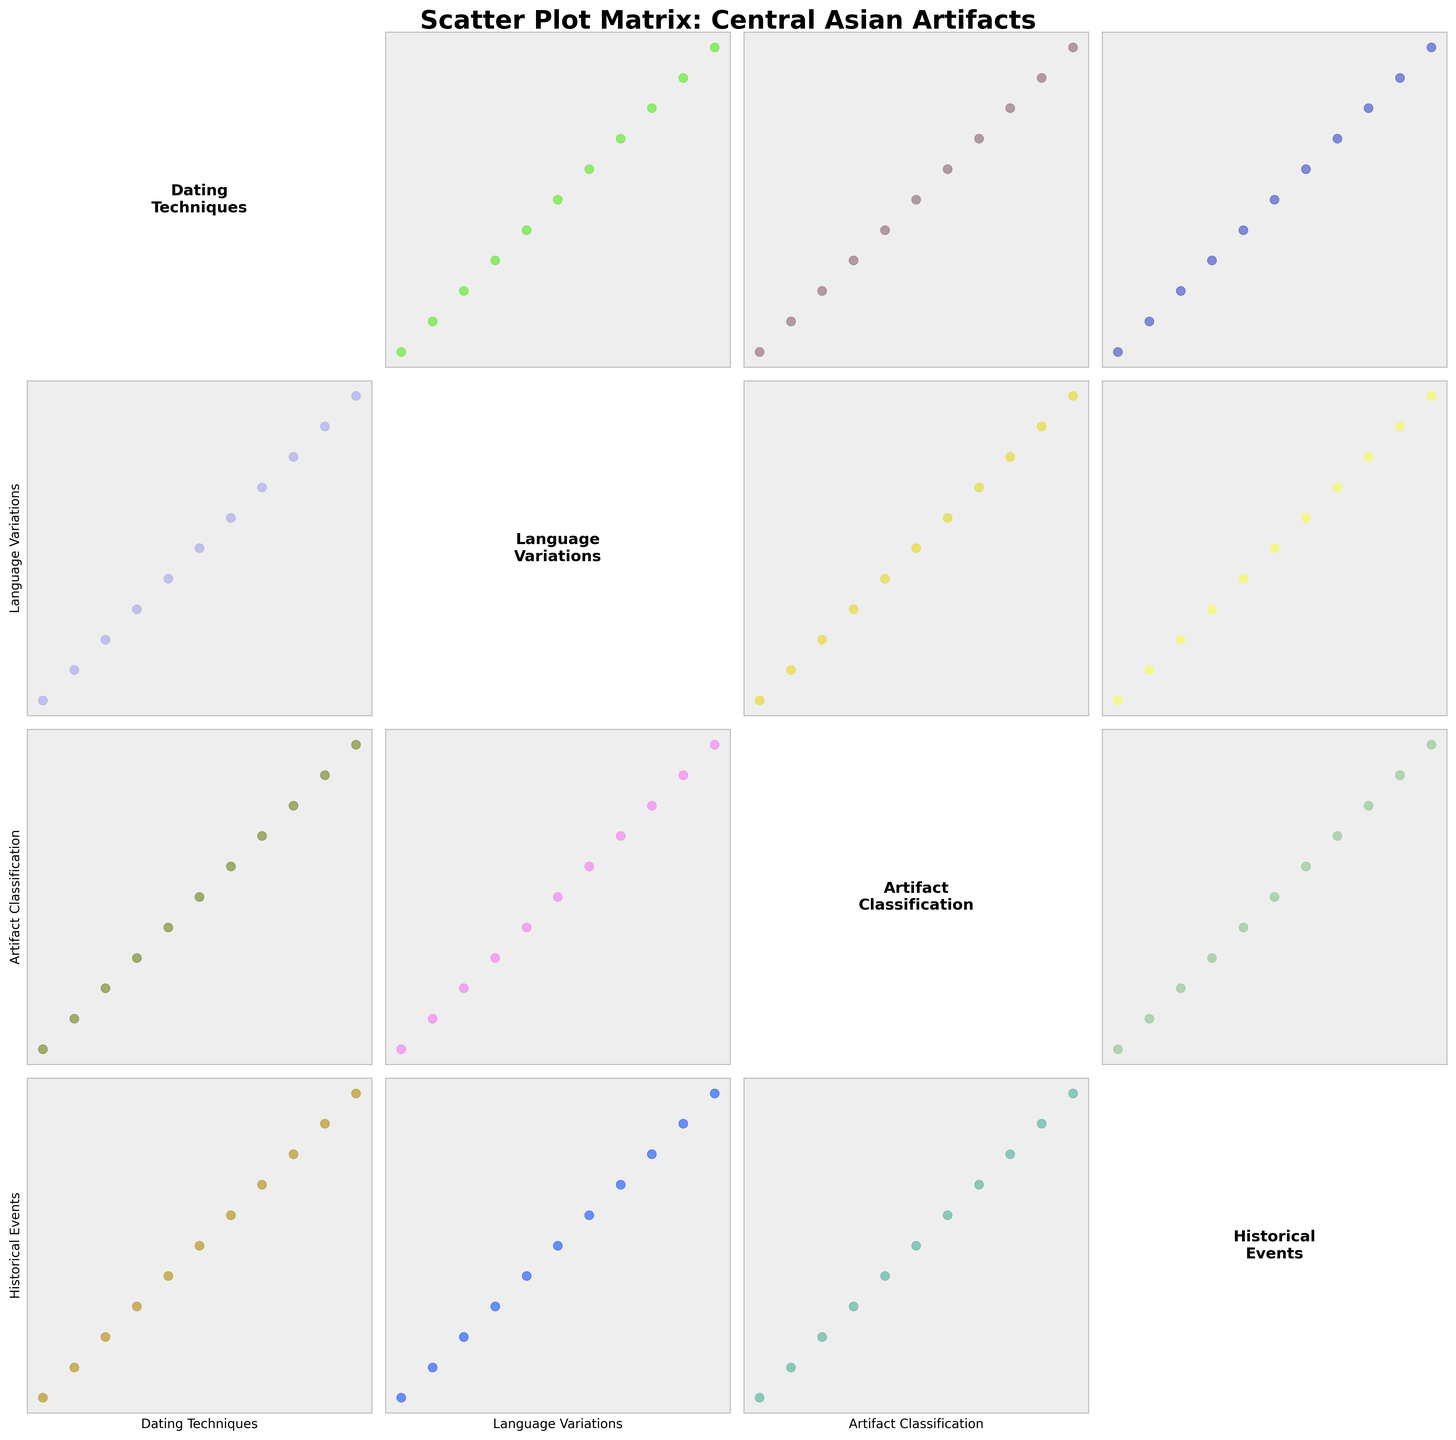what is the title of the figure? Look at the top of the figure where the title is placed. It's usually in large, bold fonts.
Answer: Scatter Plot Matrix: Central Asian Artifacts how many different categories are there in the plot? There are labels on both x and y axes; count them to get the total number of categories.
Answer: Four what are the categories compared in the scatter plot matrix? Refer to the labels on the x and y axes. Each category is labeled once.
Answer: Dating Techniques, Language Variations, Artifact Classification, Historical Events how many scatter plots are there in the matrix? The matrix has 4x4 subplots, but the diagonal ones contain text labels. So, count the off-diagonal plots.
Answer: 12 which category appears both on the x-axis and y-axis labels? Each category label is placed on both x-axis and y-axis of the plot matrix, so check for every category aligned with both axes.
Answer: Dating Techniques, Language Variations, Artifact Classification, Historical Events compare the distribution of points for 'Dating Techniques' with 'Artifact Classification' and 'Language Variations'. Which pair has more scattered points? Check the scatter plot specific to each pair. Identify which plot has a more spread distribution for 'Dating Techniques' with 'Artifact Classification' vs. 'Dating Techniques' with 'Language Variations'.
Answer: Dating Techniques vs. Artifact Classification what is unique about the plots on the diagonal of the matrix? These plots display text instead of scatter points. Each diagonal plot contains the name of the category it represents.
Answer: Text labels instead of data points which category pair shows the most clustering of data points? Look across the scatter plots and identify which category pair has data points bunching closely together compared to others.
Answer: Varies (identify by visual inspection) of the categories 'Language Variations' and 'Historical Events,' which has more varied data distribution compared when paired with 'Artifact Classification'? Compare the scatter plots of 'Language Variations' vs. 'Artifact Classification' and 'Historical Events' vs. 'Artifact Classification'. The one with wider spread of data points indicates more variation.
Answer: Varies (identify by visual inspection) how can you discern the comparative spread in the scatter plots for 'Artifact Classification' vs. 'Historical Events'? By examining the scatter plots corresponding to those pairs in the SPLOM and noting the extent of data point dispersion.
Answer: Based on visually observing dispersion 